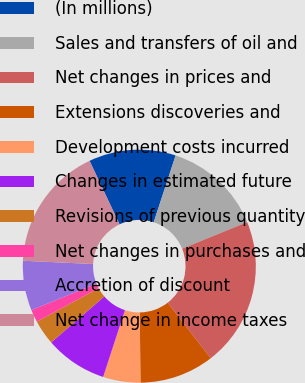Convert chart. <chart><loc_0><loc_0><loc_500><loc_500><pie_chart><fcel>(In millions)<fcel>Sales and transfers of oil and<fcel>Net changes in prices and<fcel>Extensions discoveries and<fcel>Development costs incurred<fcel>Changes in estimated future<fcel>Revisions of previous quantity<fcel>Net changes in purchases and<fcel>Accretion of discount<fcel>Net change in income taxes<nl><fcel>12.07%<fcel>13.79%<fcel>20.67%<fcel>10.34%<fcel>5.18%<fcel>8.62%<fcel>3.46%<fcel>1.74%<fcel>6.9%<fcel>17.23%<nl></chart> 